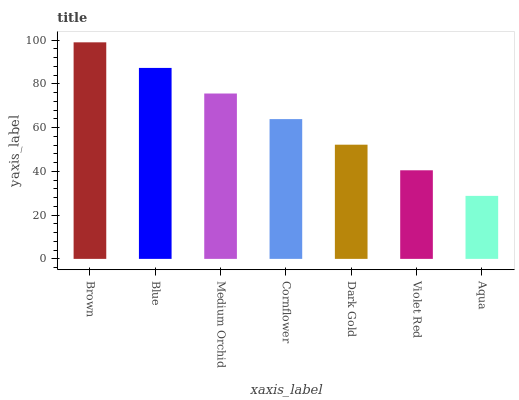Is Aqua the minimum?
Answer yes or no. Yes. Is Brown the maximum?
Answer yes or no. Yes. Is Blue the minimum?
Answer yes or no. No. Is Blue the maximum?
Answer yes or no. No. Is Brown greater than Blue?
Answer yes or no. Yes. Is Blue less than Brown?
Answer yes or no. Yes. Is Blue greater than Brown?
Answer yes or no. No. Is Brown less than Blue?
Answer yes or no. No. Is Cornflower the high median?
Answer yes or no. Yes. Is Cornflower the low median?
Answer yes or no. Yes. Is Dark Gold the high median?
Answer yes or no. No. Is Blue the low median?
Answer yes or no. No. 